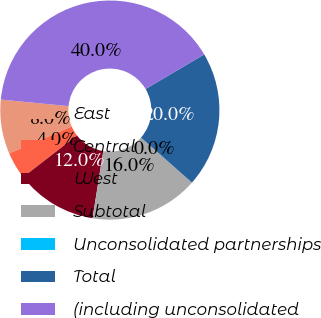Convert chart. <chart><loc_0><loc_0><loc_500><loc_500><pie_chart><fcel>East<fcel>Central<fcel>West<fcel>Subtotal<fcel>Unconsolidated partnerships<fcel>Total<fcel>(including unconsolidated<nl><fcel>8.0%<fcel>4.0%<fcel>12.0%<fcel>16.0%<fcel>0.01%<fcel>20.0%<fcel>39.99%<nl></chart> 